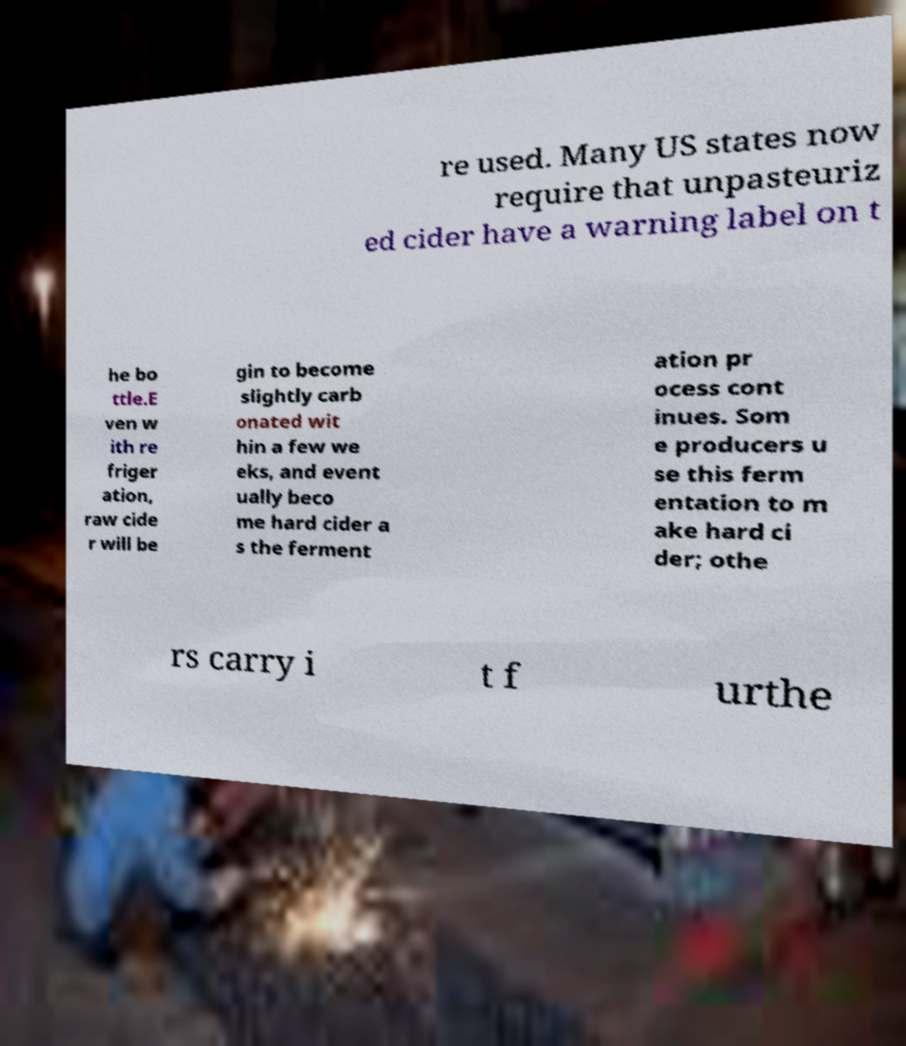Could you assist in decoding the text presented in this image and type it out clearly? re used. Many US states now require that unpasteuriz ed cider have a warning label on t he bo ttle.E ven w ith re friger ation, raw cide r will be gin to become slightly carb onated wit hin a few we eks, and event ually beco me hard cider a s the ferment ation pr ocess cont inues. Som e producers u se this ferm entation to m ake hard ci der; othe rs carry i t f urthe 